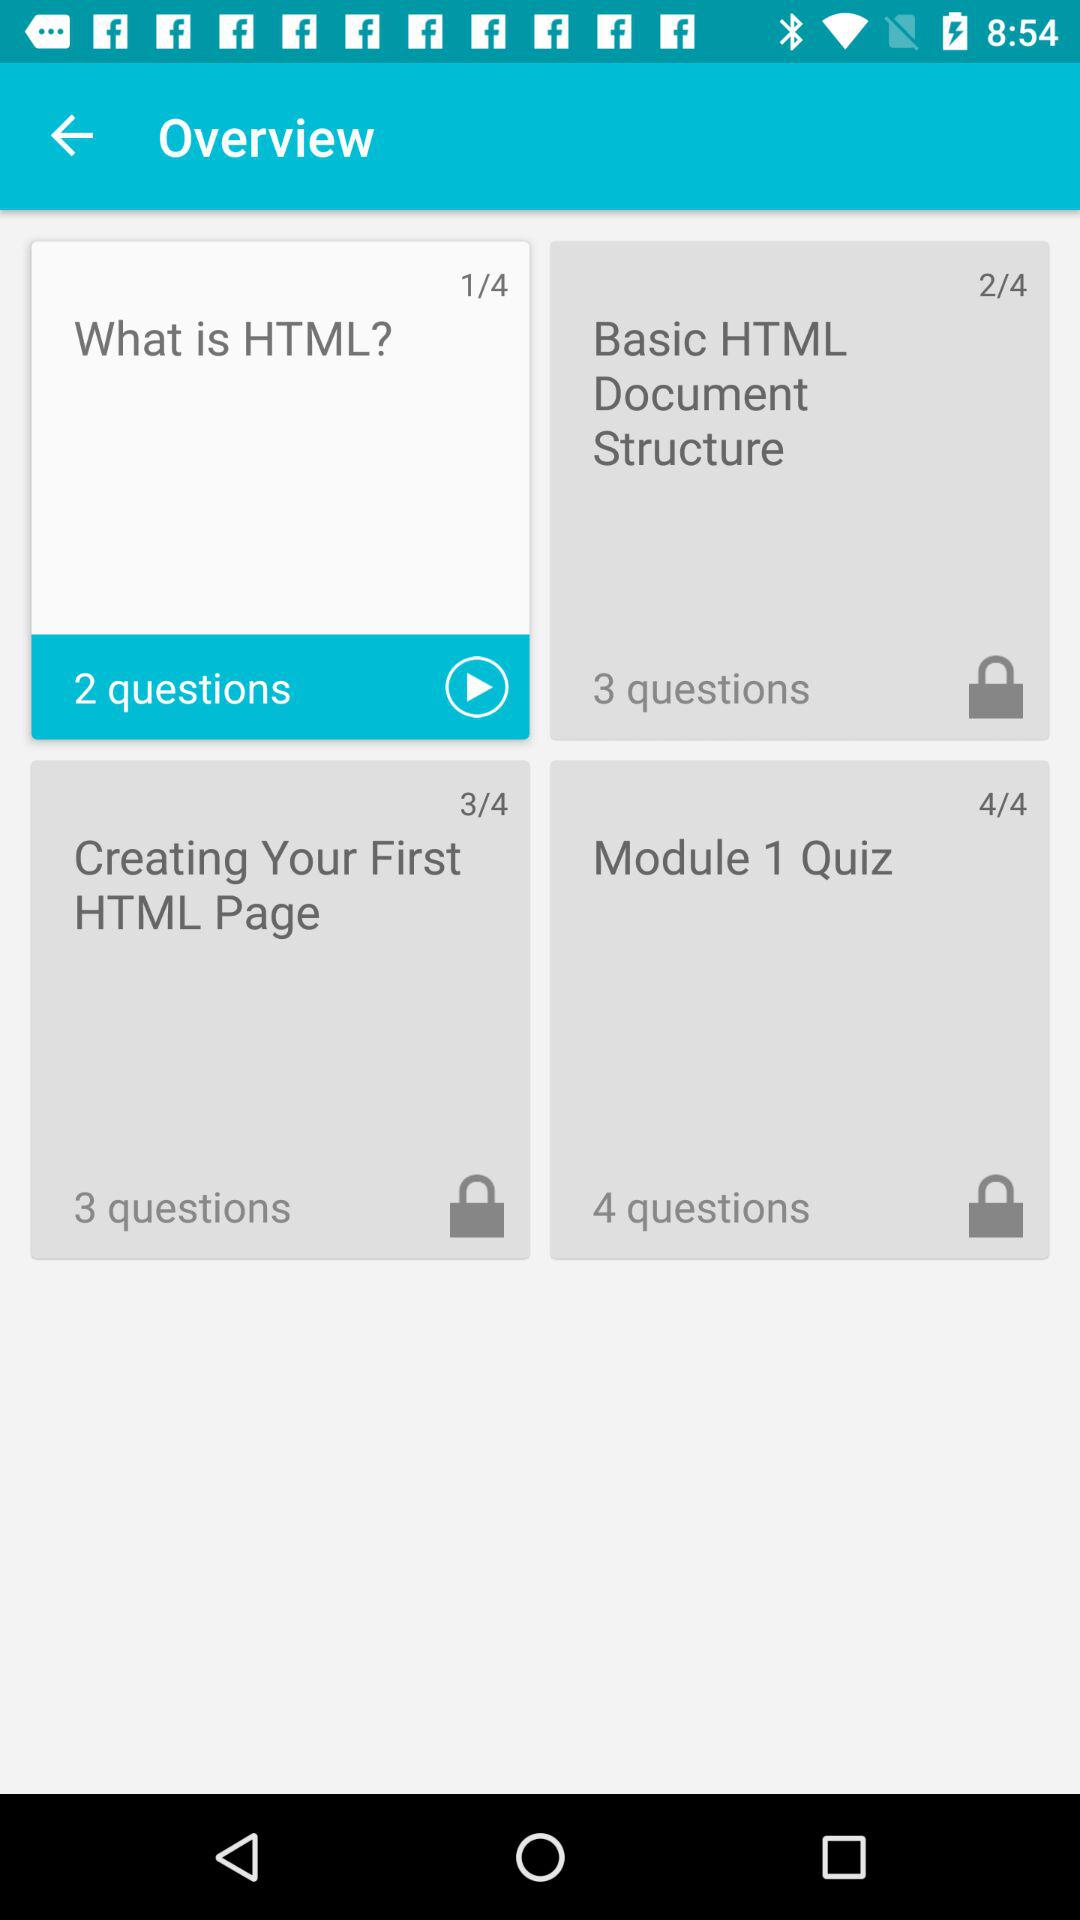How many questions are there in "Basic HTML Document Structure"? There are 3 questions. 